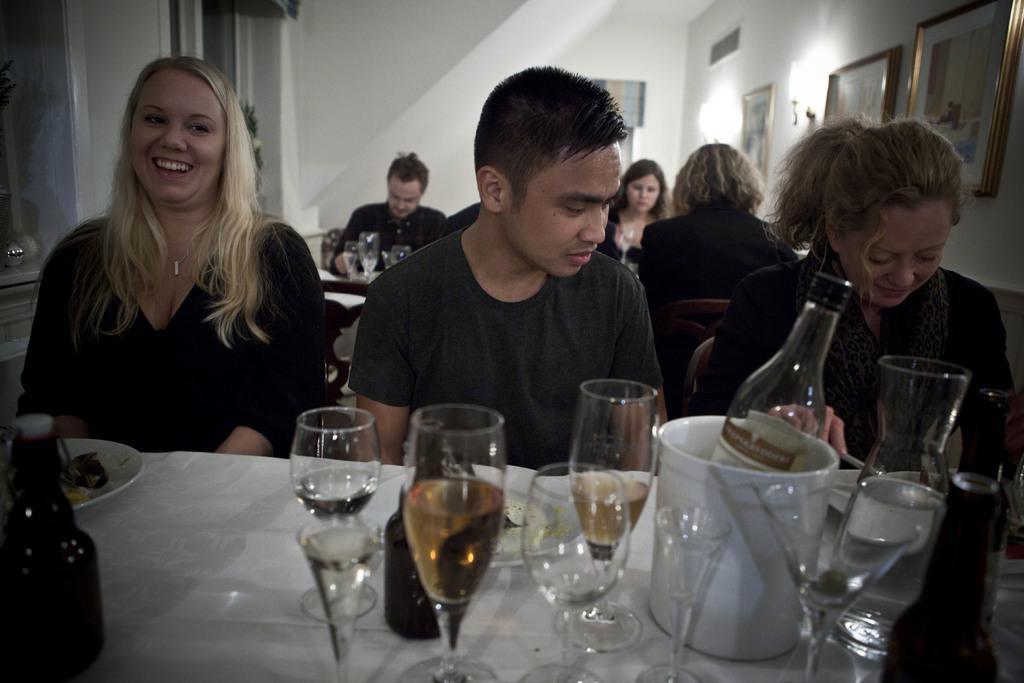Could you give a brief overview of what you see in this image? In this image we can see this people are sitting on the chairs near the table. We can see glasses, bottles, jars and plate with food on table. We can see a photo frames on the wall and people in the background. 